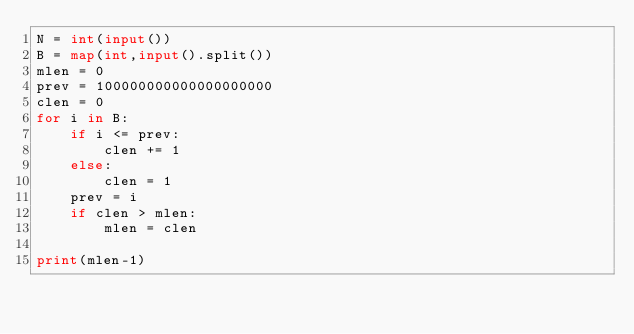Convert code to text. <code><loc_0><loc_0><loc_500><loc_500><_Python_>N = int(input())
B = map(int,input().split())
mlen = 0
prev = 100000000000000000000
clen = 0
for i in B:
    if i <= prev:
        clen += 1
    else:
        clen = 1
    prev = i
    if clen > mlen:
        mlen = clen

print(mlen-1)</code> 